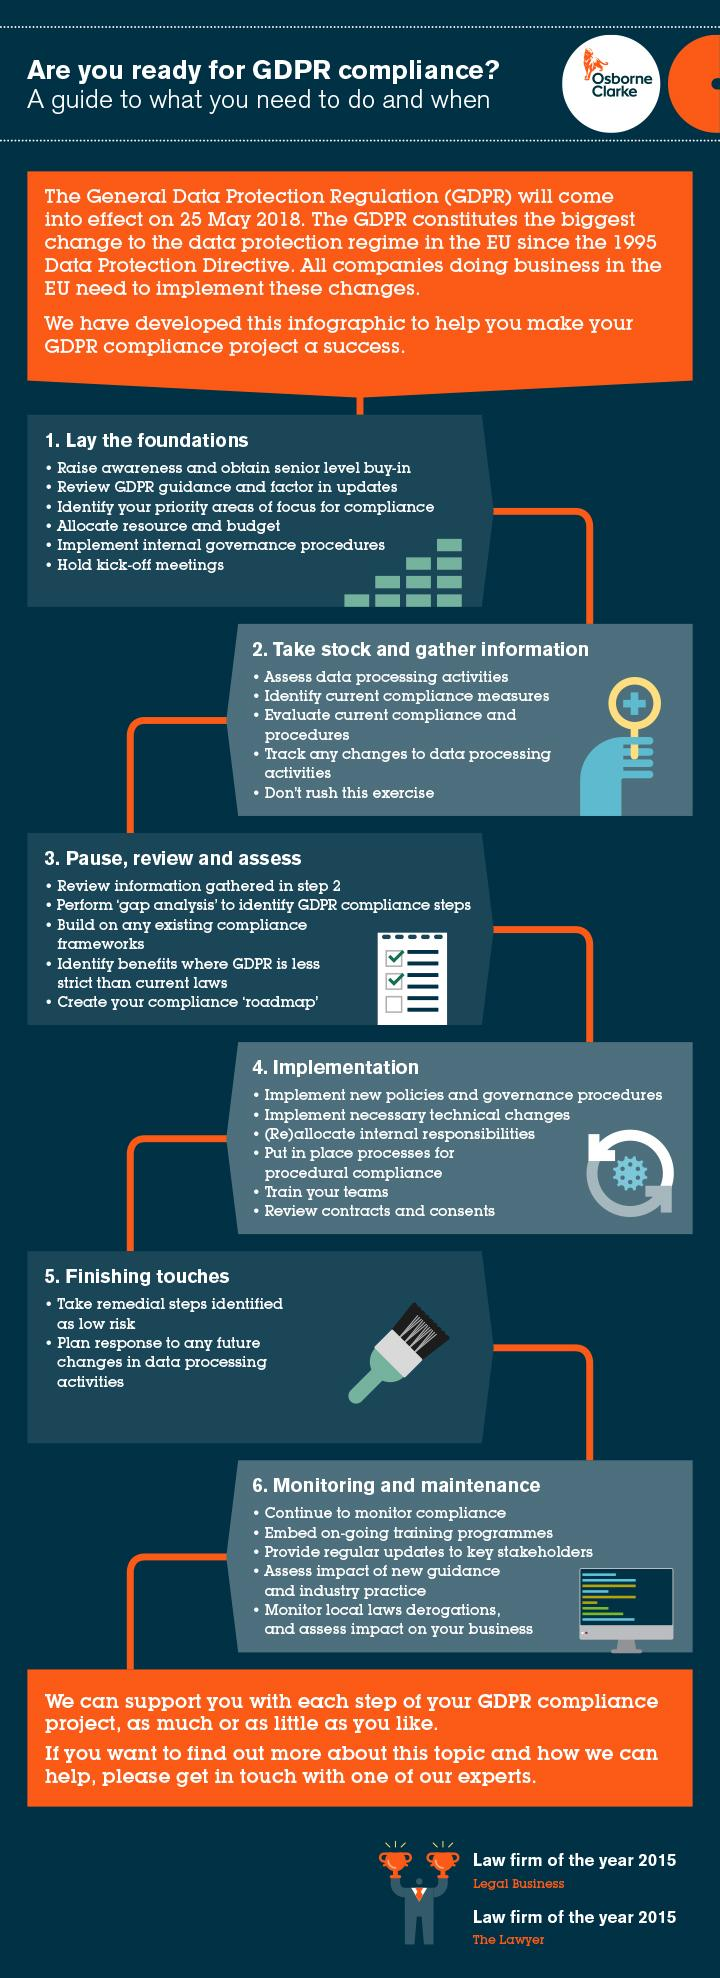Draw attention to some important aspects in this diagram. The first tip mentioned in the finishing touches step is to take remedial steps identified as low risk to ensure compliance with legal and regulatory requirements. The second tip mentioned in the laying foundations step is to review GDPR guidance and factor in updates. 